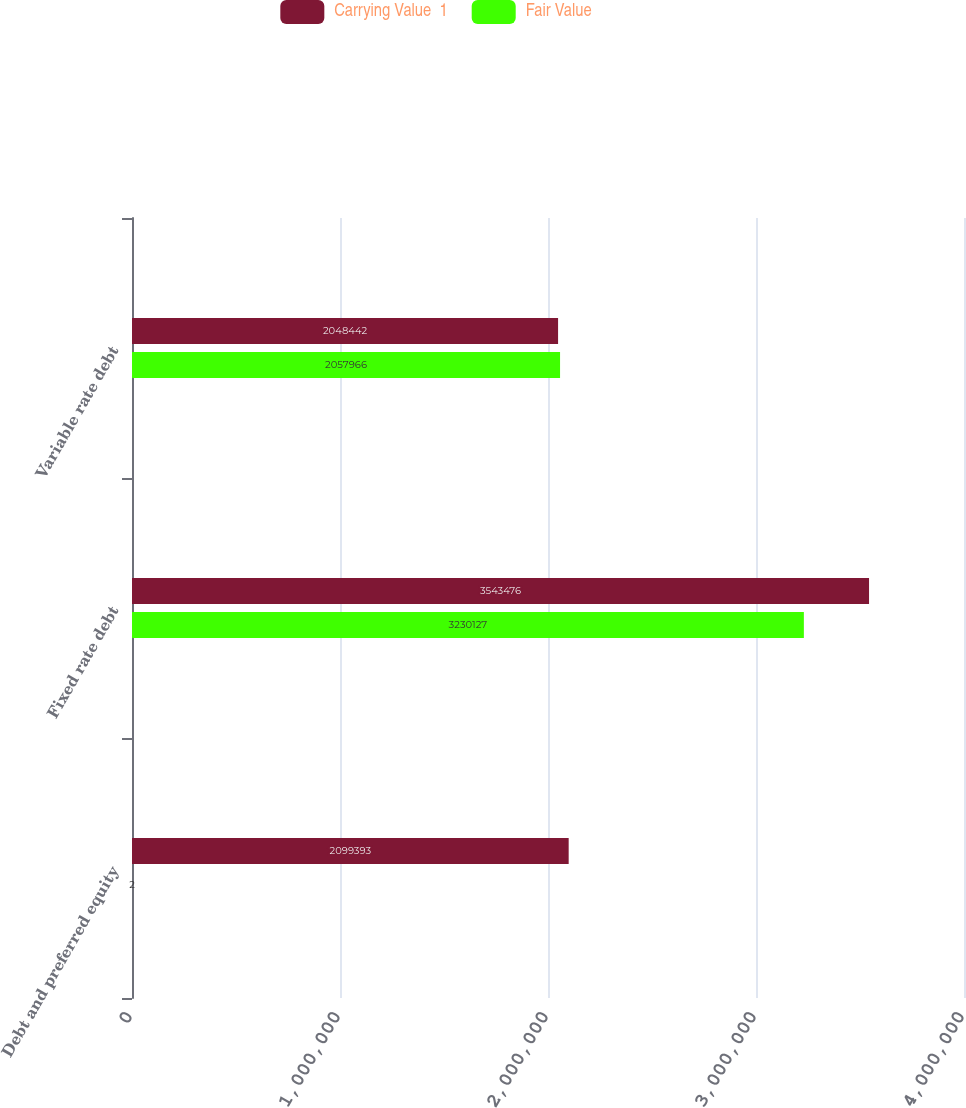Convert chart to OTSL. <chart><loc_0><loc_0><loc_500><loc_500><stacked_bar_chart><ecel><fcel>Debt and preferred equity<fcel>Fixed rate debt<fcel>Variable rate debt<nl><fcel>Carrying Value  1<fcel>2.09939e+06<fcel>3.54348e+06<fcel>2.04844e+06<nl><fcel>Fair Value<fcel>2<fcel>3.23013e+06<fcel>2.05797e+06<nl></chart> 